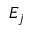Convert formula to latex. <formula><loc_0><loc_0><loc_500><loc_500>E _ { j }</formula> 